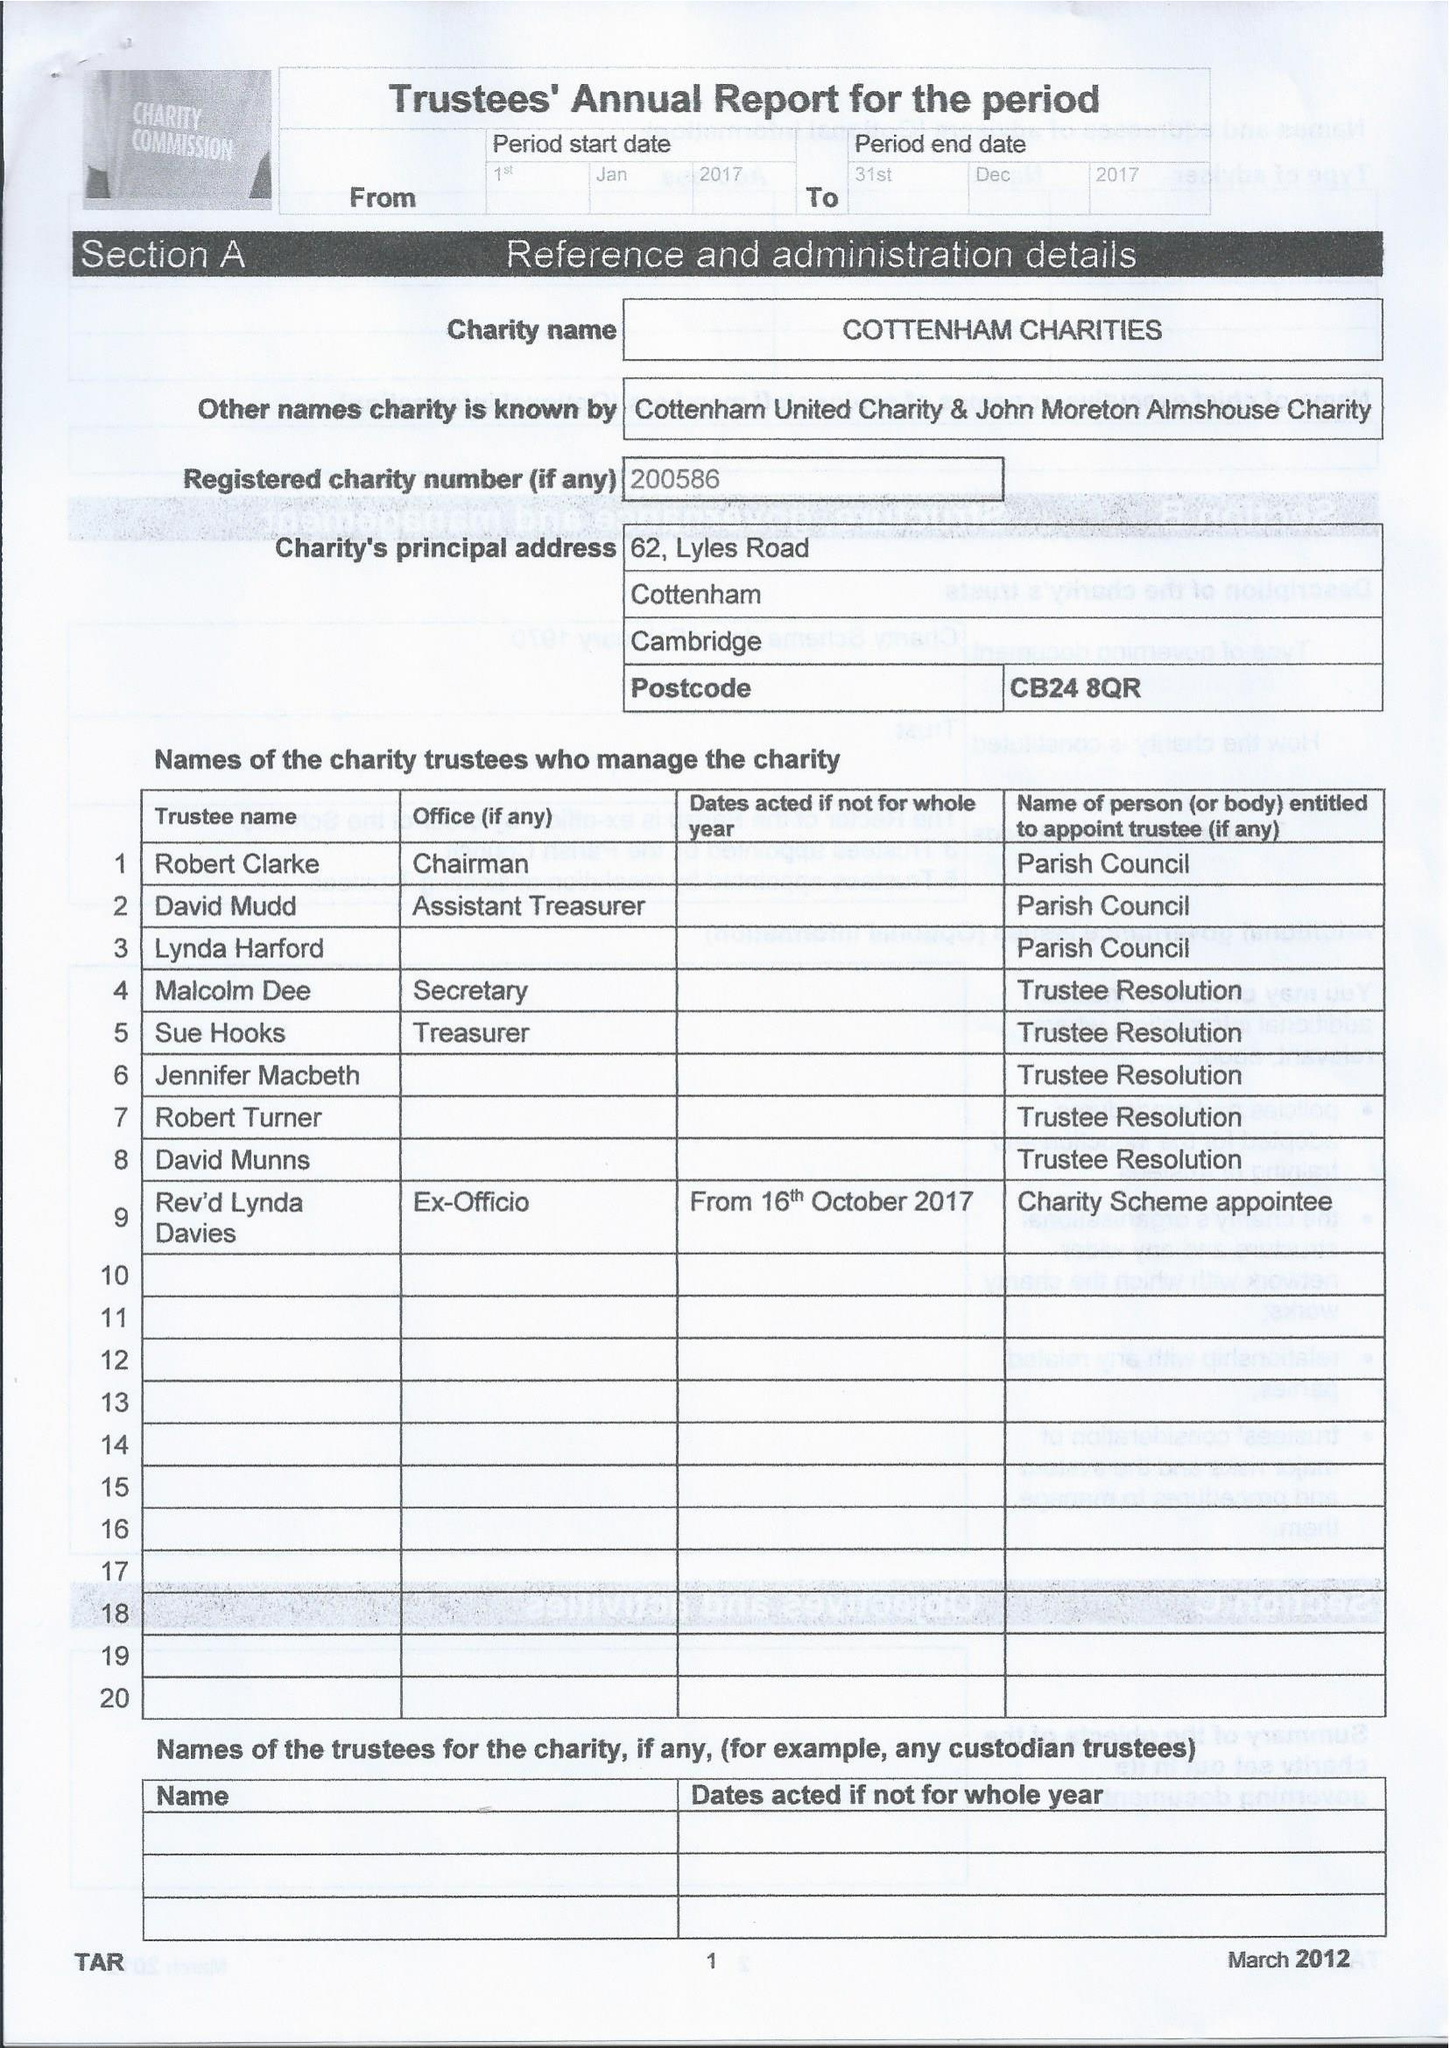What is the value for the income_annually_in_british_pounds?
Answer the question using a single word or phrase. 38779.00 